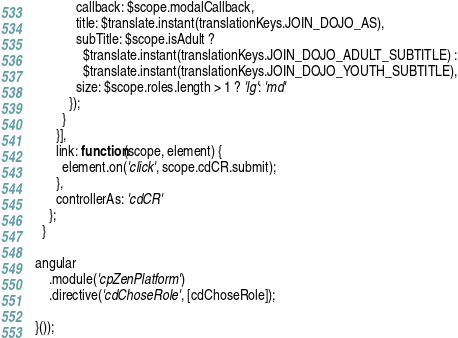<code> <loc_0><loc_0><loc_500><loc_500><_JavaScript_>            callback: $scope.modalCallback,
            title: $translate.instant(translationKeys.JOIN_DOJO_AS),
            subTitle: $scope.isAdult ?
              $translate.instant(translationKeys.JOIN_DOJO_ADULT_SUBTITLE) :
              $translate.instant(translationKeys.JOIN_DOJO_YOUTH_SUBTITLE),
            size: $scope.roles.length > 1 ? 'lg': 'md'
          });
        }
      }],
      link: function(scope, element) {
        element.on('click', scope.cdCR.submit);
      },
      controllerAs: 'cdCR'
    };
  }

angular
    .module('cpZenPlatform')
    .directive('cdChoseRole', [cdChoseRole]);

}());
</code> 